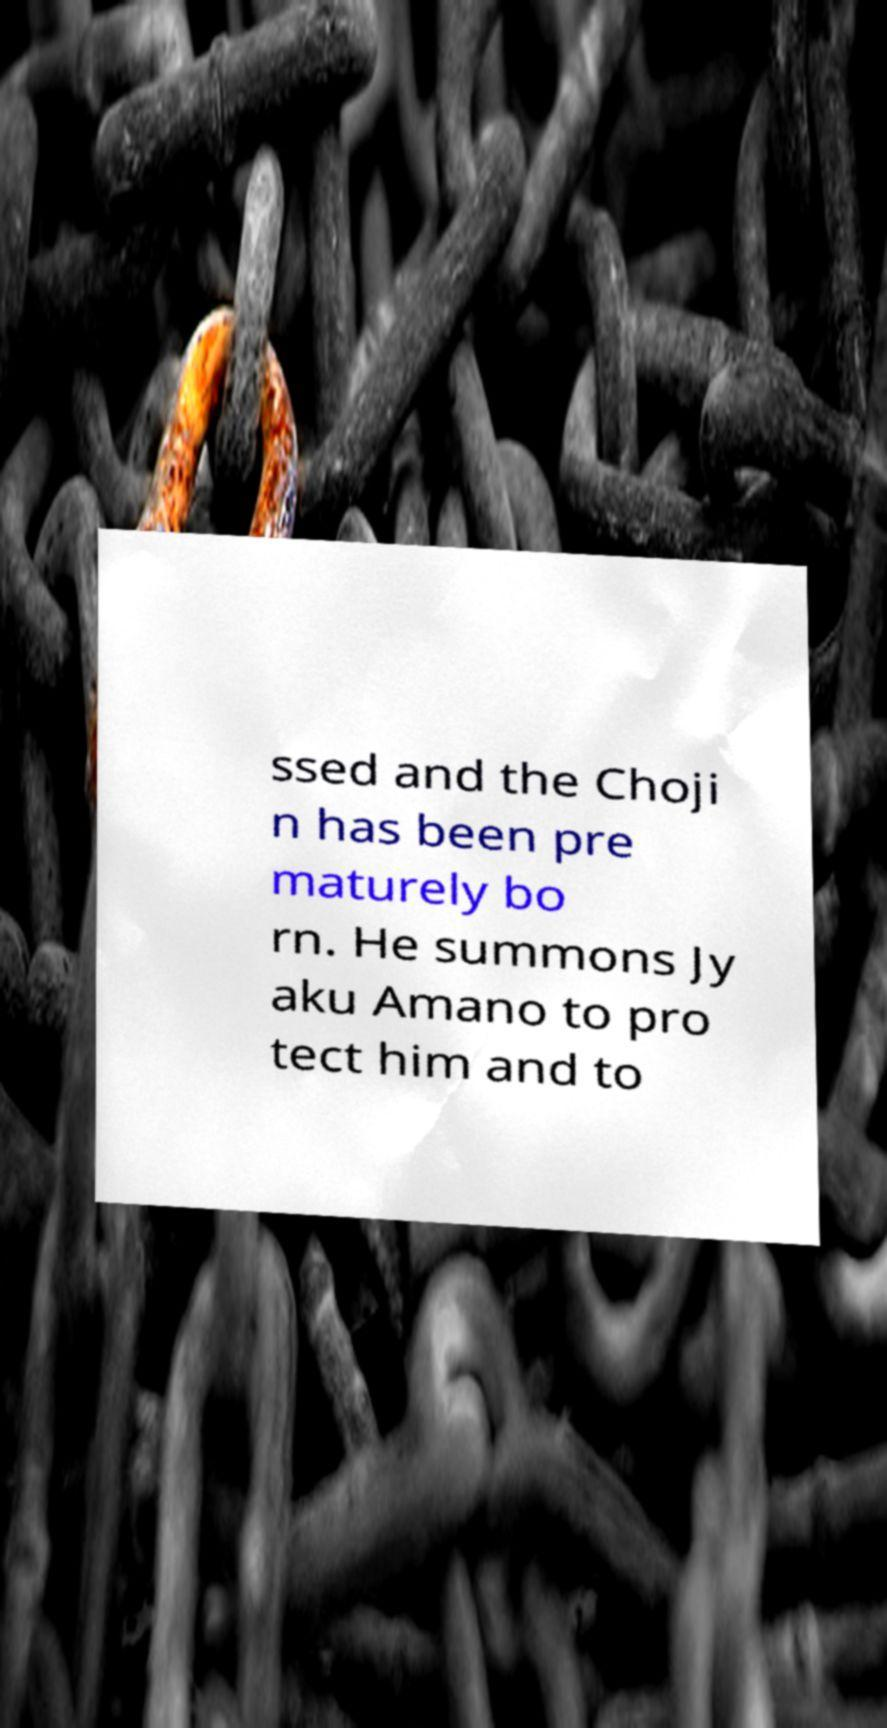Could you assist in decoding the text presented in this image and type it out clearly? ssed and the Choji n has been pre maturely bo rn. He summons Jy aku Amano to pro tect him and to 